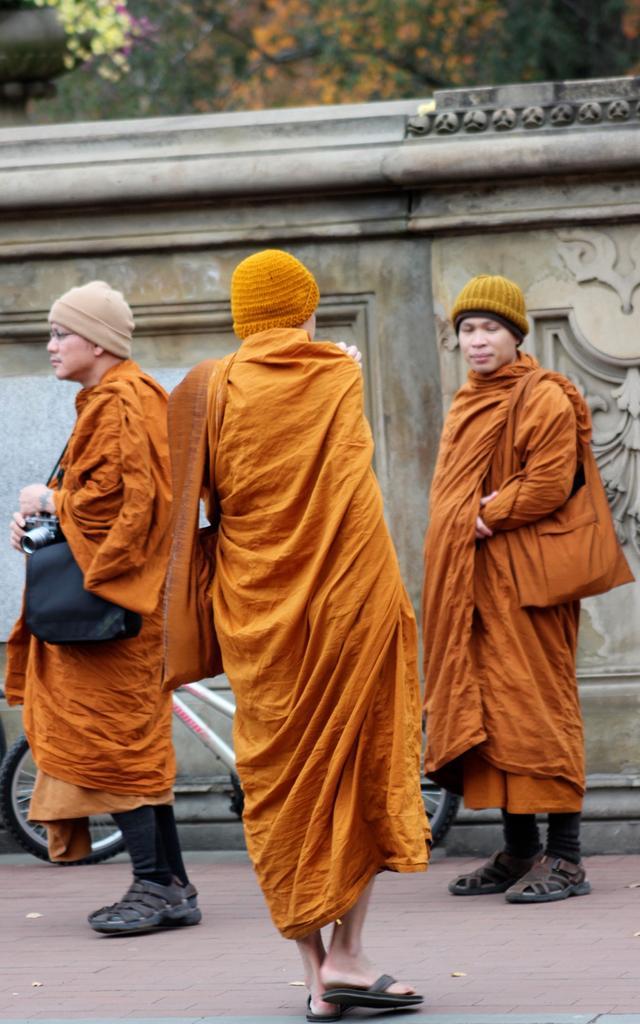Describe this image in one or two sentences. In this image there is the wall in the middle, in front of the wall, there is a bi-cycle, three persons wearing caps, bags, at the top there might be tree, in the top left there might be a flower pot, on which there are flowers visible. 